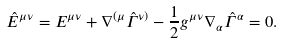Convert formula to latex. <formula><loc_0><loc_0><loc_500><loc_500>\hat { E } ^ { \mu \nu } = E ^ { \mu \nu } + \nabla ^ { ( \mu } \hat { \Gamma } ^ { \nu ) } - \frac { 1 } { 2 } g ^ { \mu \nu } \nabla _ { \alpha } \hat { \Gamma } ^ { \alpha } = 0 .</formula> 